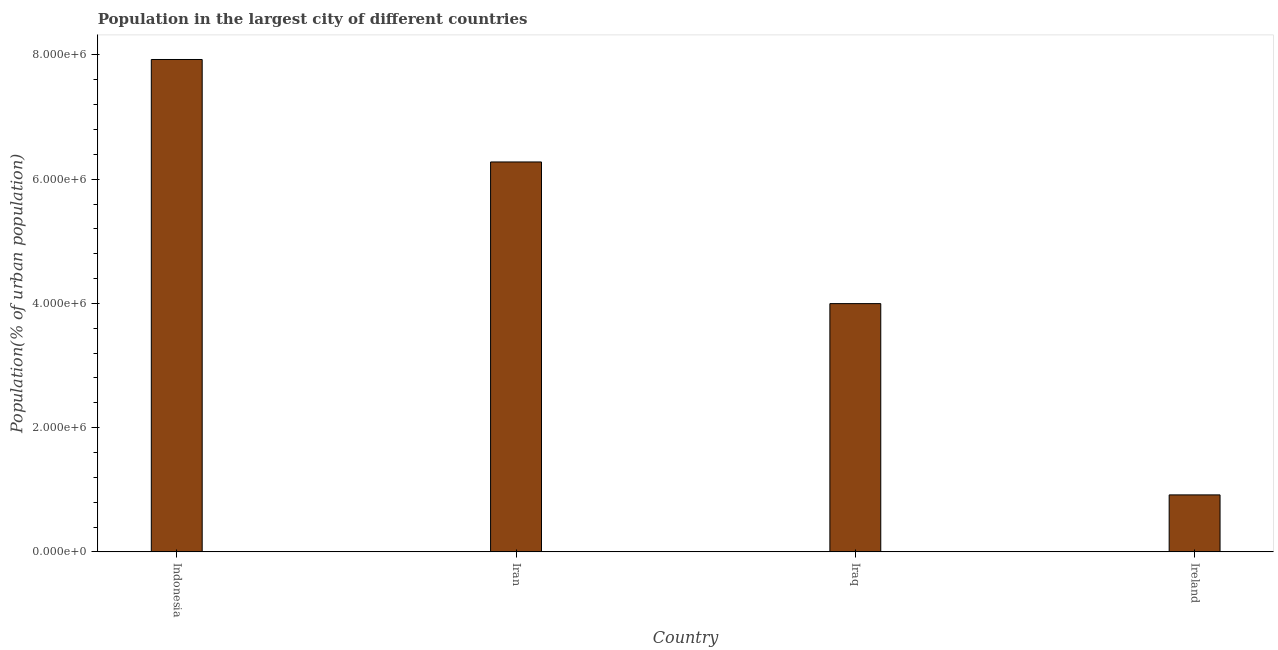Does the graph contain any zero values?
Your answer should be very brief. No. What is the title of the graph?
Your answer should be very brief. Population in the largest city of different countries. What is the label or title of the Y-axis?
Your response must be concise. Population(% of urban population). What is the population in largest city in Iran?
Provide a succinct answer. 6.28e+06. Across all countries, what is the maximum population in largest city?
Provide a succinct answer. 7.93e+06. Across all countries, what is the minimum population in largest city?
Make the answer very short. 9.17e+05. In which country was the population in largest city maximum?
Your answer should be very brief. Indonesia. In which country was the population in largest city minimum?
Make the answer very short. Ireland. What is the sum of the population in largest city?
Your response must be concise. 1.91e+07. What is the difference between the population in largest city in Iran and Iraq?
Offer a very short reply. 2.28e+06. What is the average population in largest city per country?
Offer a terse response. 4.78e+06. What is the median population in largest city?
Offer a very short reply. 5.14e+06. In how many countries, is the population in largest city greater than 2400000 %?
Provide a succinct answer. 3. What is the ratio of the population in largest city in Iran to that in Ireland?
Provide a succinct answer. 6.84. Is the population in largest city in Indonesia less than that in Iran?
Ensure brevity in your answer.  No. Is the difference between the population in largest city in Iran and Iraq greater than the difference between any two countries?
Your answer should be very brief. No. What is the difference between the highest and the second highest population in largest city?
Your answer should be very brief. 1.65e+06. What is the difference between the highest and the lowest population in largest city?
Provide a succinct answer. 7.01e+06. What is the difference between two consecutive major ticks on the Y-axis?
Offer a very short reply. 2.00e+06. Are the values on the major ticks of Y-axis written in scientific E-notation?
Offer a very short reply. Yes. What is the Population(% of urban population) in Indonesia?
Your answer should be compact. 7.93e+06. What is the Population(% of urban population) of Iran?
Offer a terse response. 6.28e+06. What is the Population(% of urban population) in Iraq?
Give a very brief answer. 4.00e+06. What is the Population(% of urban population) in Ireland?
Make the answer very short. 9.17e+05. What is the difference between the Population(% of urban population) in Indonesia and Iran?
Keep it short and to the point. 1.65e+06. What is the difference between the Population(% of urban population) in Indonesia and Iraq?
Your answer should be compact. 3.93e+06. What is the difference between the Population(% of urban population) in Indonesia and Ireland?
Offer a very short reply. 7.01e+06. What is the difference between the Population(% of urban population) in Iran and Iraq?
Offer a terse response. 2.28e+06. What is the difference between the Population(% of urban population) in Iran and Ireland?
Your response must be concise. 5.36e+06. What is the difference between the Population(% of urban population) in Iraq and Ireland?
Your answer should be very brief. 3.08e+06. What is the ratio of the Population(% of urban population) in Indonesia to that in Iran?
Give a very brief answer. 1.26. What is the ratio of the Population(% of urban population) in Indonesia to that in Iraq?
Provide a succinct answer. 1.98. What is the ratio of the Population(% of urban population) in Indonesia to that in Ireland?
Ensure brevity in your answer.  8.64. What is the ratio of the Population(% of urban population) in Iran to that in Iraq?
Make the answer very short. 1.57. What is the ratio of the Population(% of urban population) in Iran to that in Ireland?
Your answer should be compact. 6.84. What is the ratio of the Population(% of urban population) in Iraq to that in Ireland?
Provide a short and direct response. 4.36. 